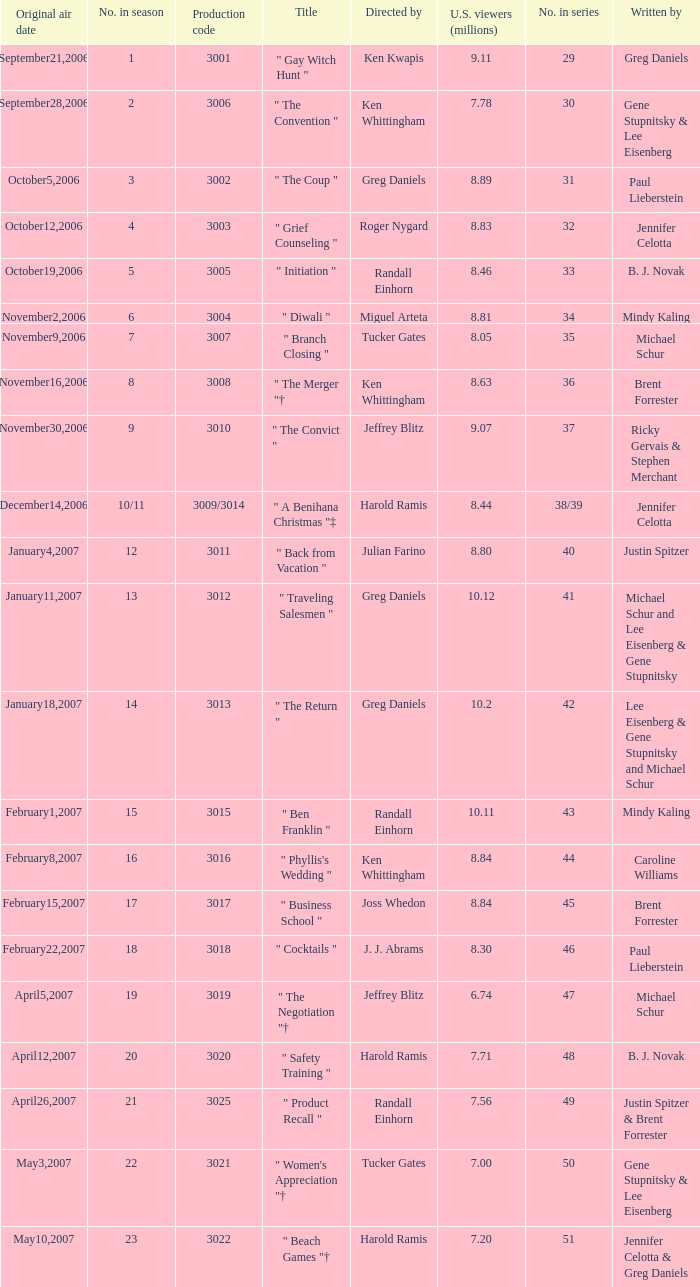Name the number in the series for when the viewers is 7.78 30.0. 